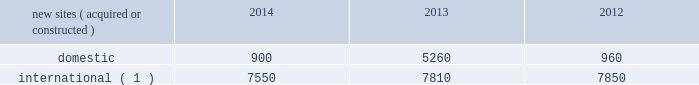Rental and management operations new site revenue growth .
During the year ended december 31 , 2014 , we grew our portfolio of communications real estate through the acquisition and construction of approximately 8450 sites .
In a majority of our international markets , the acquisition or construction of new sites results in increased pass-through revenues ( such as ground rent or power and fuel costs ) and expenses .
We continue to evaluate opportunities to acquire communications real estate portfolios , both domestically and internationally , to determine whether they meet our risk-adjusted hurdle rates and whether we believe we can effectively integrate them into our existing portfolio. .
( 1 ) the majority of sites acquired or constructed in 2014 were in brazil , india and mexico ; in 2013 were in brazil , colombia , costa rica , india , mexico and south africa ; and in 2012 were in brazil , germany , india and uganda .
Rental and management operations expenses .
Direct operating expenses incurred by our domestic and international rental and management segments include direct site level expenses and consist primarily of ground rent and power and fuel costs , some of which may be passed through to our tenants , as well as property taxes , repairs and maintenance .
These segment direct operating expenses exclude all segment and corporate selling , general , administrative and development expenses , which are aggregated into one line item entitled selling , general , administrative and development expense in our consolidated statements of operations .
In general , our domestic and international rental and management segments 2019 selling , general , administrative and development expenses do not significantly increase as a result of adding incremental tenants to our legacy sites and typically increase only modestly year-over-year .
As a result , leasing additional space to new tenants on our legacy sites provides significant incremental cash flow .
We may , however , incur additional segment selling , general , administrative and development expenses as we increase our presence in geographic areas where we have recently launched operations or are focused on expanding our portfolio .
Our profit margin growth is therefore positively impacted by the addition of new tenants to our legacy sites and can be temporarily diluted by our development activities .
Network development services segment revenue growth .
As we continue to focus on growing our rental and management operations , we anticipate that our network development services revenue will continue to represent a small percentage of our total revenues .
Non-gaap financial measures included in our analysis of our results of operations are discussions regarding earnings before interest , taxes , depreciation , amortization and accretion , as adjusted ( 201cadjusted ebitda 201d ) , funds from operations , as defined by the national association of real estate investment trusts ( 201cnareit ffo 201d ) and adjusted funds from operations ( 201caffo 201d ) .
We define adjusted ebitda as net income before income ( loss ) on discontinued operations , net ; income ( loss ) on equity method investments ; income tax benefit ( provision ) ; other income ( expense ) ; gain ( loss ) on retirement of long-term obligations ; interest expense ; interest income ; other operating income ( expense ) ; depreciation , amortization and accretion ; and stock-based compensation expense .
Nareit ffo is defined as net income before gains or losses from the sale or disposal of real estate , real estate related impairment charges , real estate related depreciation , amortization and accretion and dividends declared on preferred stock , and including adjustments for ( i ) unconsolidated affiliates and ( ii ) noncontrolling interest. .
In 2014 , how many of the new sites were forweign? 
Computations: (7550 / (900 + 7550))
Answer: 0.89349. 